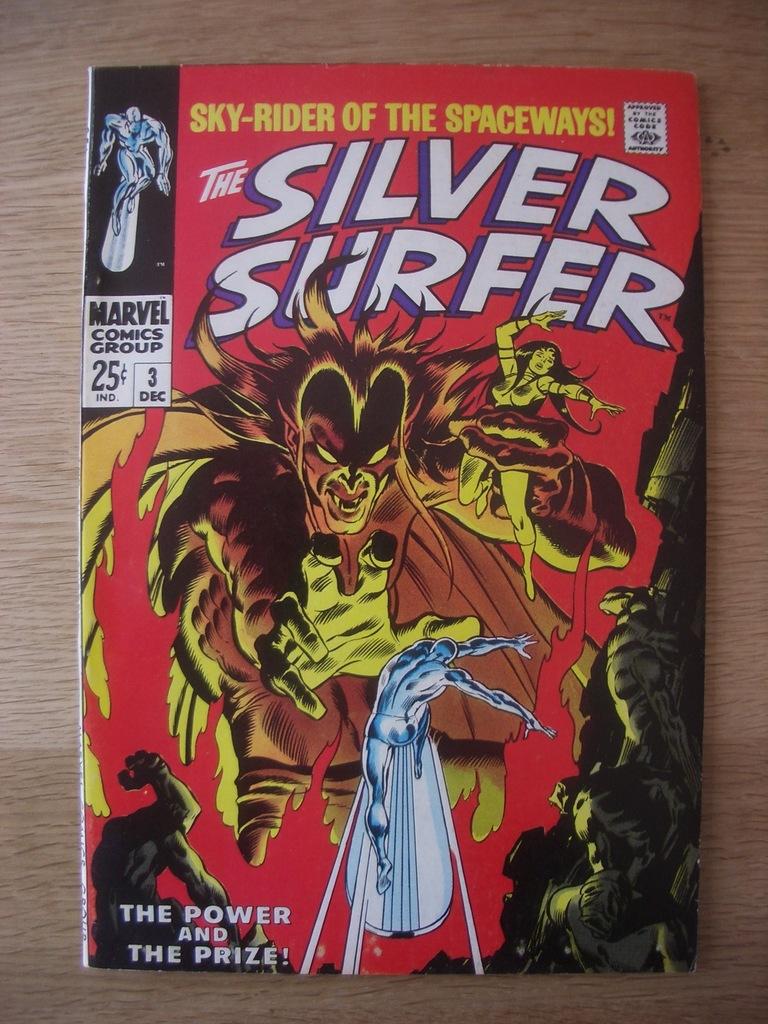Is the comic book silver surfer good?
Your response must be concise. Unanswerable. What is the title?
Offer a terse response. The silver surfer. 